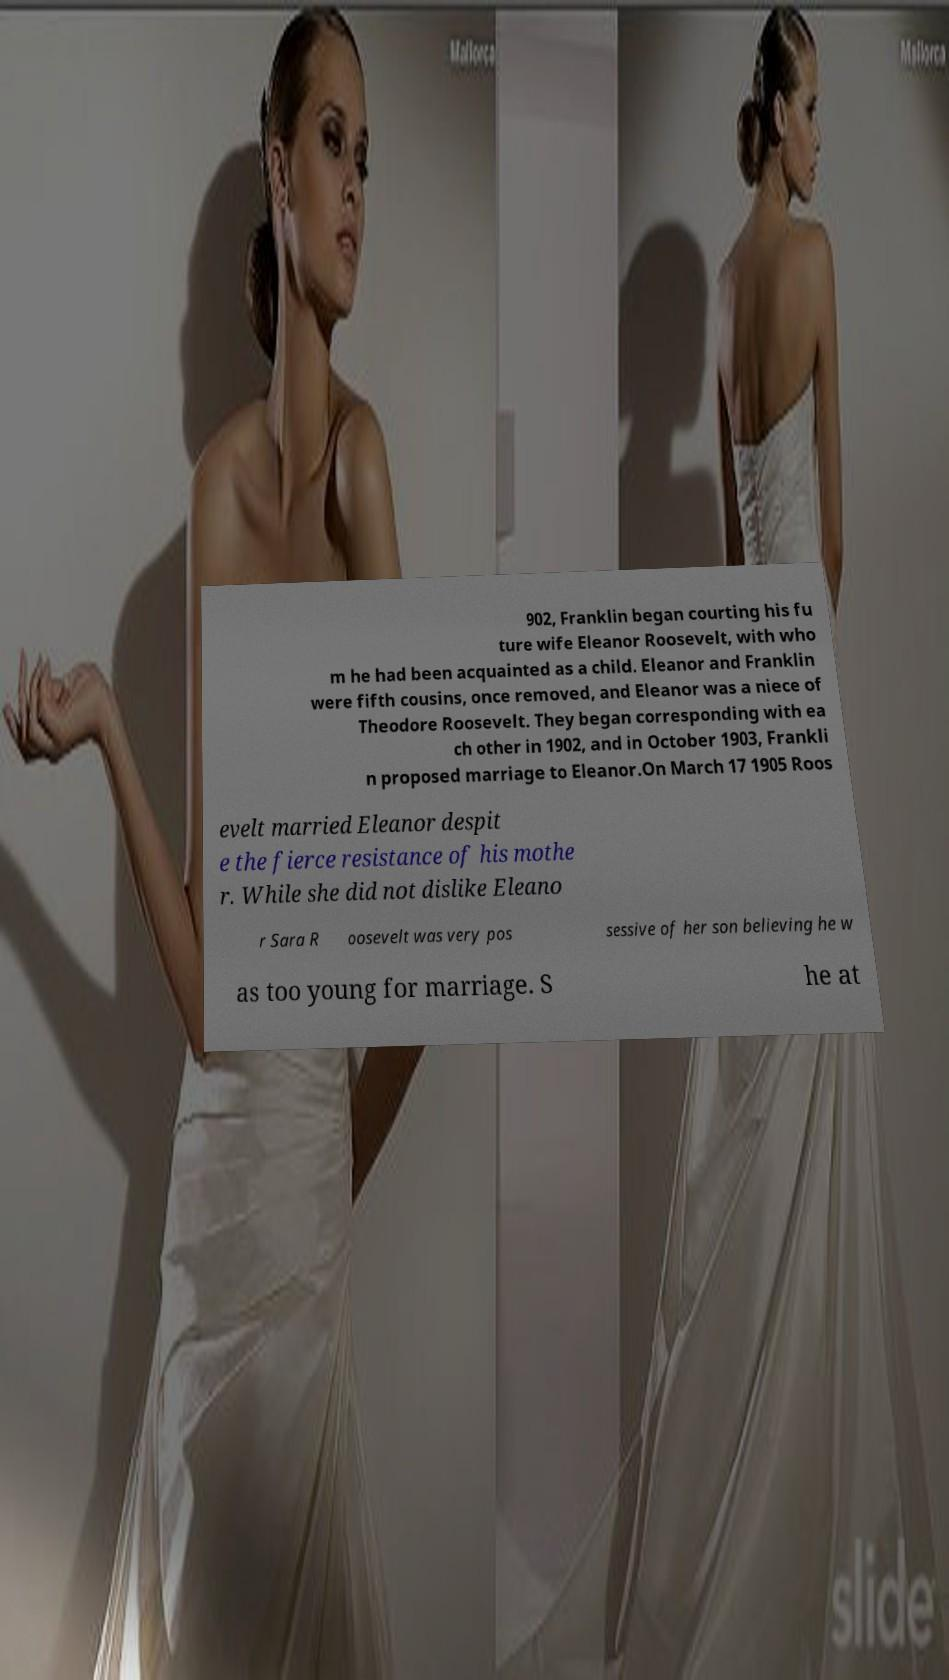What messages or text are displayed in this image? I need them in a readable, typed format. 902, Franklin began courting his fu ture wife Eleanor Roosevelt, with who m he had been acquainted as a child. Eleanor and Franklin were fifth cousins, once removed, and Eleanor was a niece of Theodore Roosevelt. They began corresponding with ea ch other in 1902, and in October 1903, Frankli n proposed marriage to Eleanor.On March 17 1905 Roos evelt married Eleanor despit e the fierce resistance of his mothe r. While she did not dislike Eleano r Sara R oosevelt was very pos sessive of her son believing he w as too young for marriage. S he at 